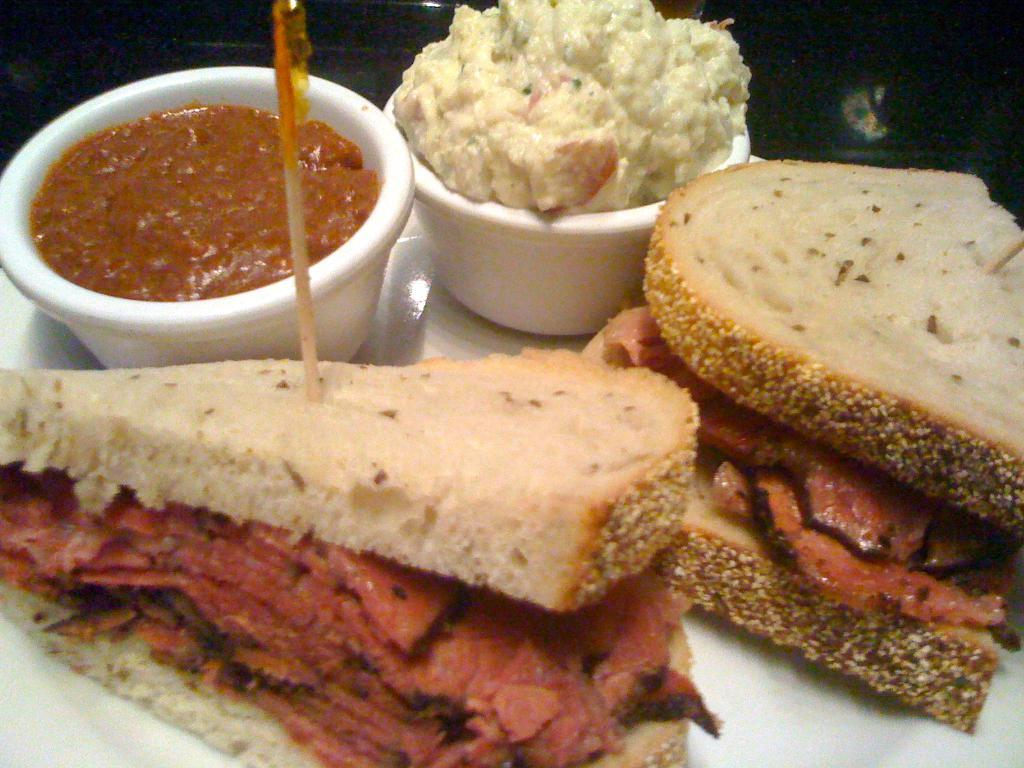What is on the serving plate in the image? The serving plate has stuffed sandwiches on it. What accompanies the stuffed sandwiches on the plate? There are two bowls of dips in the image. What type of trail can be seen in the image? There is no trail present in the image; it features a serving plate with stuffed sandwiches and two bowls of dips. 